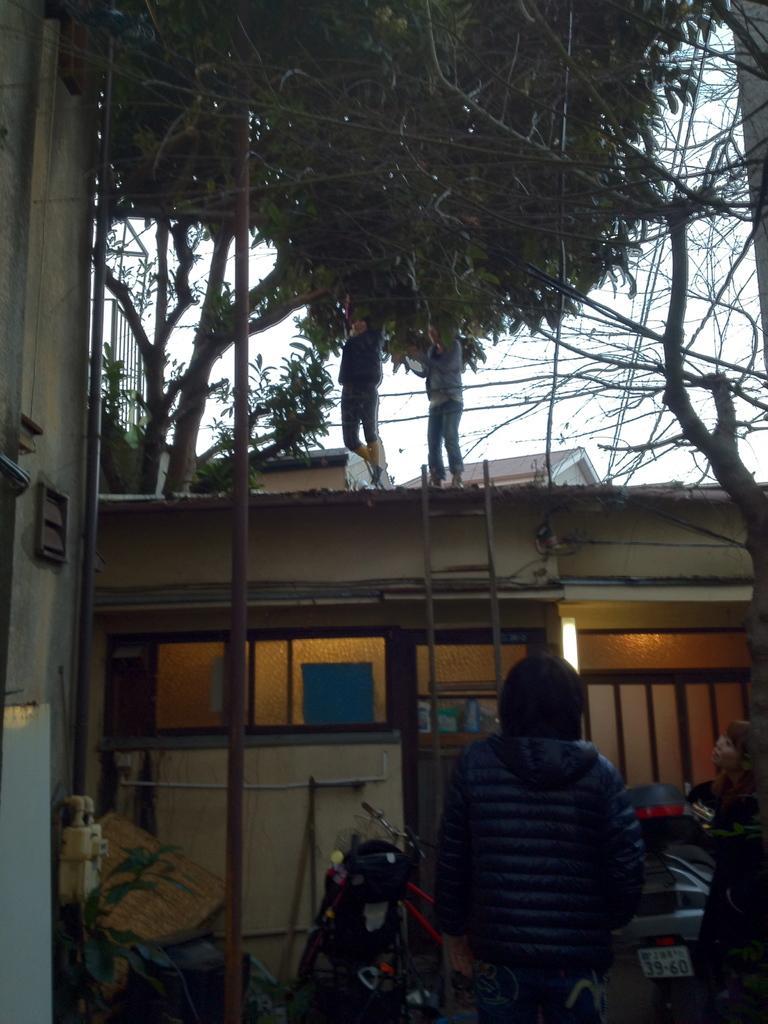Describe this image in one or two sentences. In the bottom right corner of the image two persons are standing. In front of them we can see motorcycles and bicycles. Behind them there are some houses, trees, poles and ladder. Two persons are holding tree. Behind the tree there is sky. 